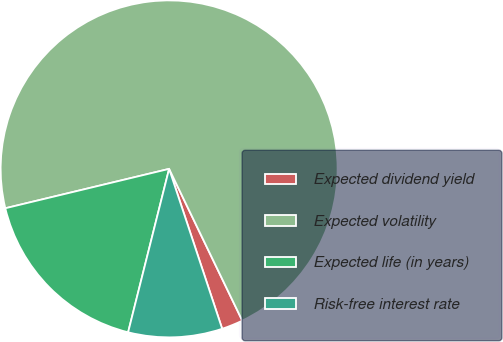<chart> <loc_0><loc_0><loc_500><loc_500><pie_chart><fcel>Expected dividend yield<fcel>Expected volatility<fcel>Expected life (in years)<fcel>Risk-free interest rate<nl><fcel>2.05%<fcel>71.6%<fcel>17.33%<fcel>9.01%<nl></chart> 